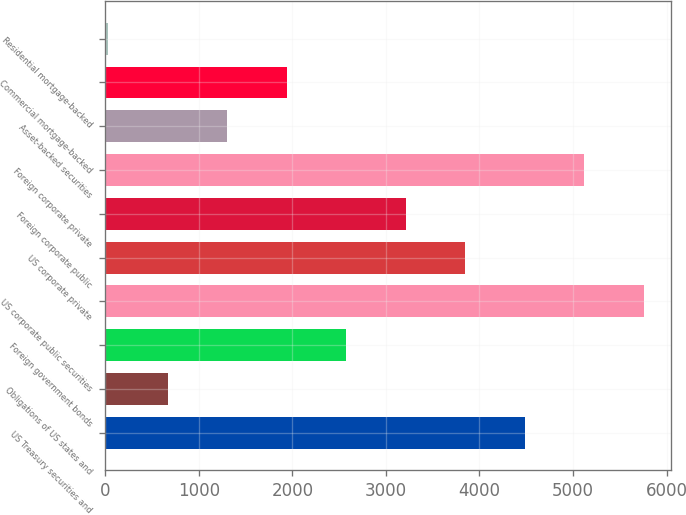Convert chart to OTSL. <chart><loc_0><loc_0><loc_500><loc_500><bar_chart><fcel>US Treasury securities and<fcel>Obligations of US states and<fcel>Foreign government bonds<fcel>US corporate public securities<fcel>US corporate private<fcel>Foreign corporate public<fcel>Foreign corporate private<fcel>Asset-backed securities<fcel>Commercial mortgage-backed<fcel>Residential mortgage-backed<nl><fcel>4483.3<fcel>667.9<fcel>2575.6<fcel>5755.1<fcel>3847.4<fcel>3211.5<fcel>5119.2<fcel>1303.8<fcel>1939.7<fcel>32<nl></chart> 